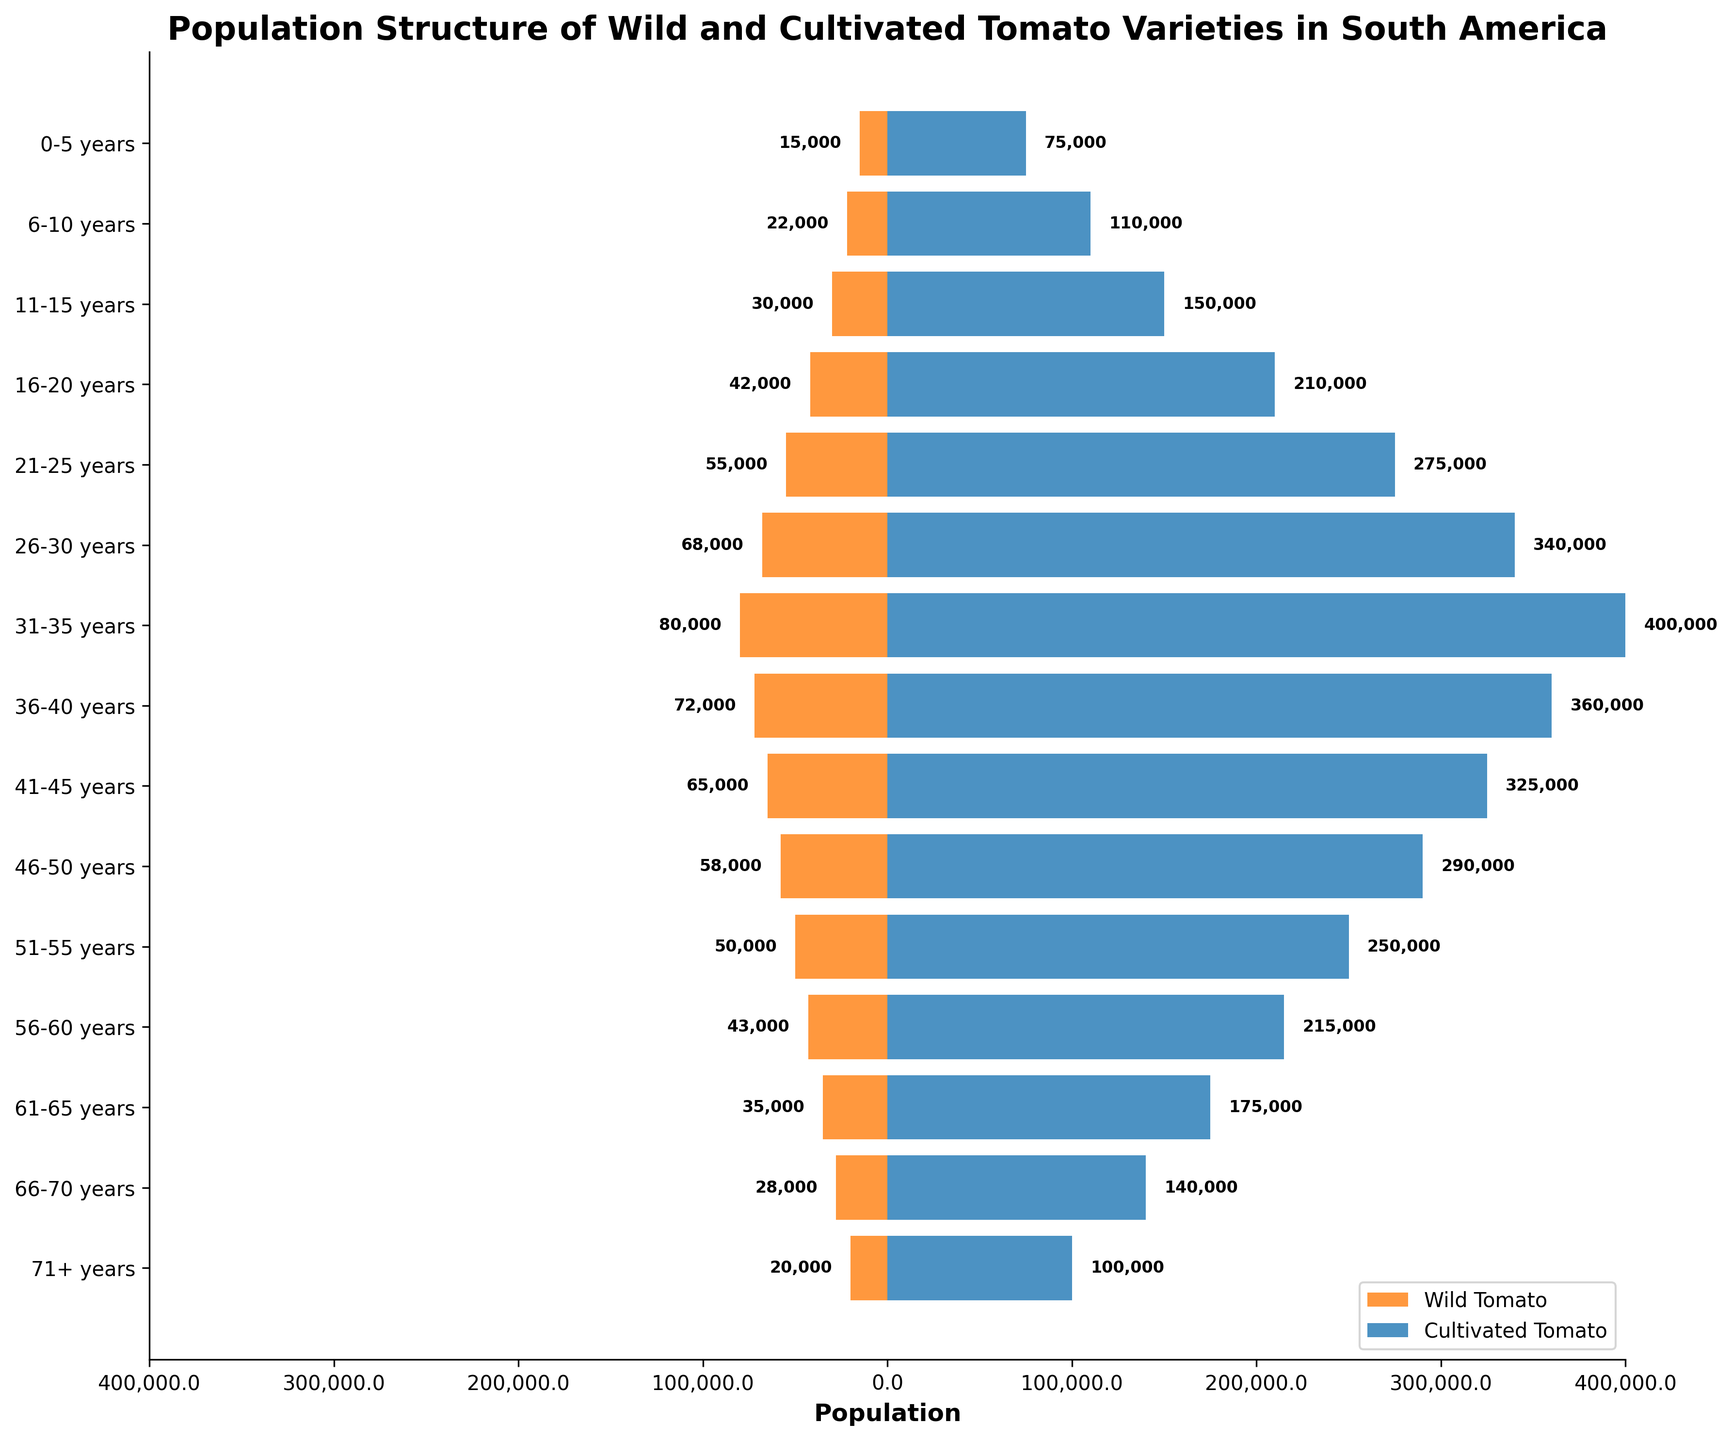What is the total population of wild tomato in the 21-25 years age group? Locate the age group "21-25 years" and find the corresponding value in the Wild Tomato column, which is 55,000.
Answer: 55,000 What is the difference in population between the 31-35 years groups of wild and cultivated tomatoes? Locate the age group "31-35 years" and find the values for Wild Tomato (80,000) and Cultivated Tomato (400,000). Subtract the former from the latter: 400,000 - 80,000 = 320,000.
Answer: 320,000 Which age group has the highest population of wild tomatoes? Examine the Wild Tomato column to find the largest value, which is 80,000 in the "31-35 years" age group.
Answer: 31-35 years What is the ratio of cultivated to wild tomatoes in the 11-15 years age group? Locate the values for the age group "11-15 years": Wild Tomato (30,000) and Cultivated Tomato (150,000). The ratio is 150,000 / 30,000 = 5.
Answer: 5 Is there any age group where the wild tomato population is greater than the cultivated tomato population? Compare the values in each age group. For every age group, the population of cultivated tomatoes is greater than that of wild tomatoes.
Answer: No By how much does the population of wild tomatoes decrease from the 31-35 years age group to the 51-55 years age group? Locate the values for Wild Tomato: 31-35 years (80,000) and 51-55 years (50,000). Subtract the latter from the former: 80,000 - 50,000 = 30,000.
Answer: 30,000 Which age group has the smallest difference between wild and cultivated tomato populations? Calculate the difference between wild and cultivated tomato populations for each age group. The smallest difference is in the "0-5 years" age group, with a difference of 75,000 - 15,000 = 60,000.
Answer: 0-5 years What proportion of the total cultivated tomato population does the 41-45 years age group represent? First, sum the total population of cultivated tomatoes: 1,275,000. Then locate the 41-45 years value: 325,000. Calculate the proportion: 325,000 / 1,275,000 ≈ 0.255.
Answer: 0.255 What trend do you observe in the wild tomato populations as the age group increases from 0-5 to 71+? The wild tomato population generally increases from the 0-5 years age group to the 31-35 years age group, then decreases gradually towards the 71+ years group.
Answer: Increasing then decreasing How does the total population of cultivated tomatoes compare to that of wild tomatoes? Sum the total populations: 55,000 + 275,000 + 150,000 + ... + 100,000 = 2,237,000 (Cultivated Tomato), and 15,000 + 22,000 + 30,000 + … + 20,000 = 434,000 (Wild Tomato). The total cultivated population is much greater.
Answer: Cultivated > Wild 